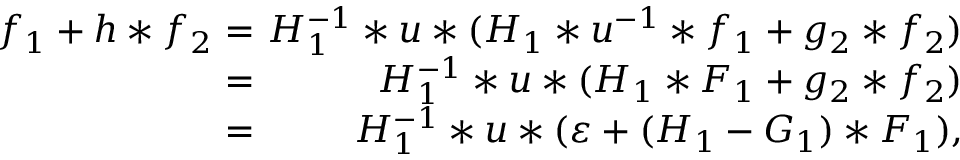Convert formula to latex. <formula><loc_0><loc_0><loc_500><loc_500>\begin{array} { r l r } { f _ { 1 } + h \ast f _ { 2 } \, } & { = } & { \, H _ { 1 } ^ { - 1 } \ast u \ast ( H _ { 1 } \ast u ^ { - 1 } \ast f _ { 1 } + g _ { 2 } \ast f _ { 2 } ) } \\ { \, } & { = } & { \, H _ { 1 } ^ { - 1 } \ast u \ast ( H _ { 1 } \ast F _ { 1 } + g _ { 2 } \ast f _ { 2 } ) } \\ { \, } & { = } & { \, H _ { 1 } ^ { - 1 } \ast u \ast ( \varepsilon + ( H _ { 1 } - G _ { 1 } ) \ast F _ { 1 } ) , } \end{array}</formula> 